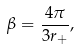<formula> <loc_0><loc_0><loc_500><loc_500>\beta = \frac { 4 \pi } { 3 r _ { + } } ,</formula> 